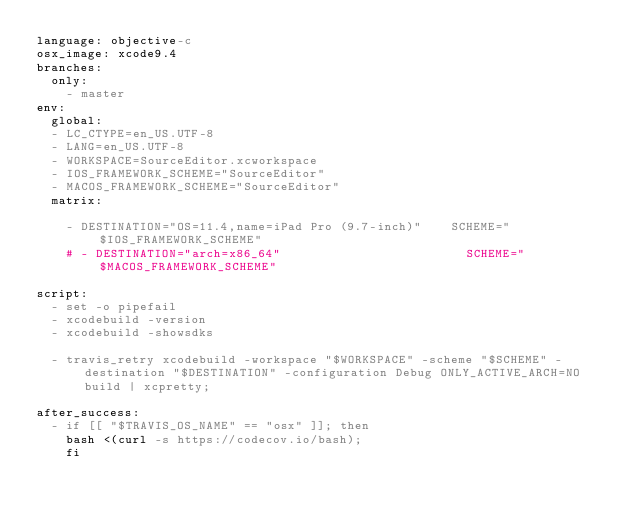Convert code to text. <code><loc_0><loc_0><loc_500><loc_500><_YAML_>language: objective-c
osx_image: xcode9.4
branches:
  only:
    - master
env:
  global:
  - LC_CTYPE=en_US.UTF-8
  - LANG=en_US.UTF-8
  - WORKSPACE=SourceEditor.xcworkspace
  - IOS_FRAMEWORK_SCHEME="SourceEditor"
  - MACOS_FRAMEWORK_SCHEME="SourceEditor"
  matrix:

    - DESTINATION="OS=11.4,name=iPad Pro (9.7-inch)"    SCHEME="$IOS_FRAMEWORK_SCHEME"
    # - DESTINATION="arch=x86_64"                         SCHEME="$MACOS_FRAMEWORK_SCHEME" 

script:
  - set -o pipefail
  - xcodebuild -version
  - xcodebuild -showsdks

  - travis_retry xcodebuild -workspace "$WORKSPACE" -scheme "$SCHEME" -destination "$DESTINATION" -configuration Debug ONLY_ACTIVE_ARCH=NO build | xcpretty;

after_success:
  - if [[ "$TRAVIS_OS_NAME" == "osx" ]]; then
    bash <(curl -s https://codecov.io/bash);
    fi</code> 